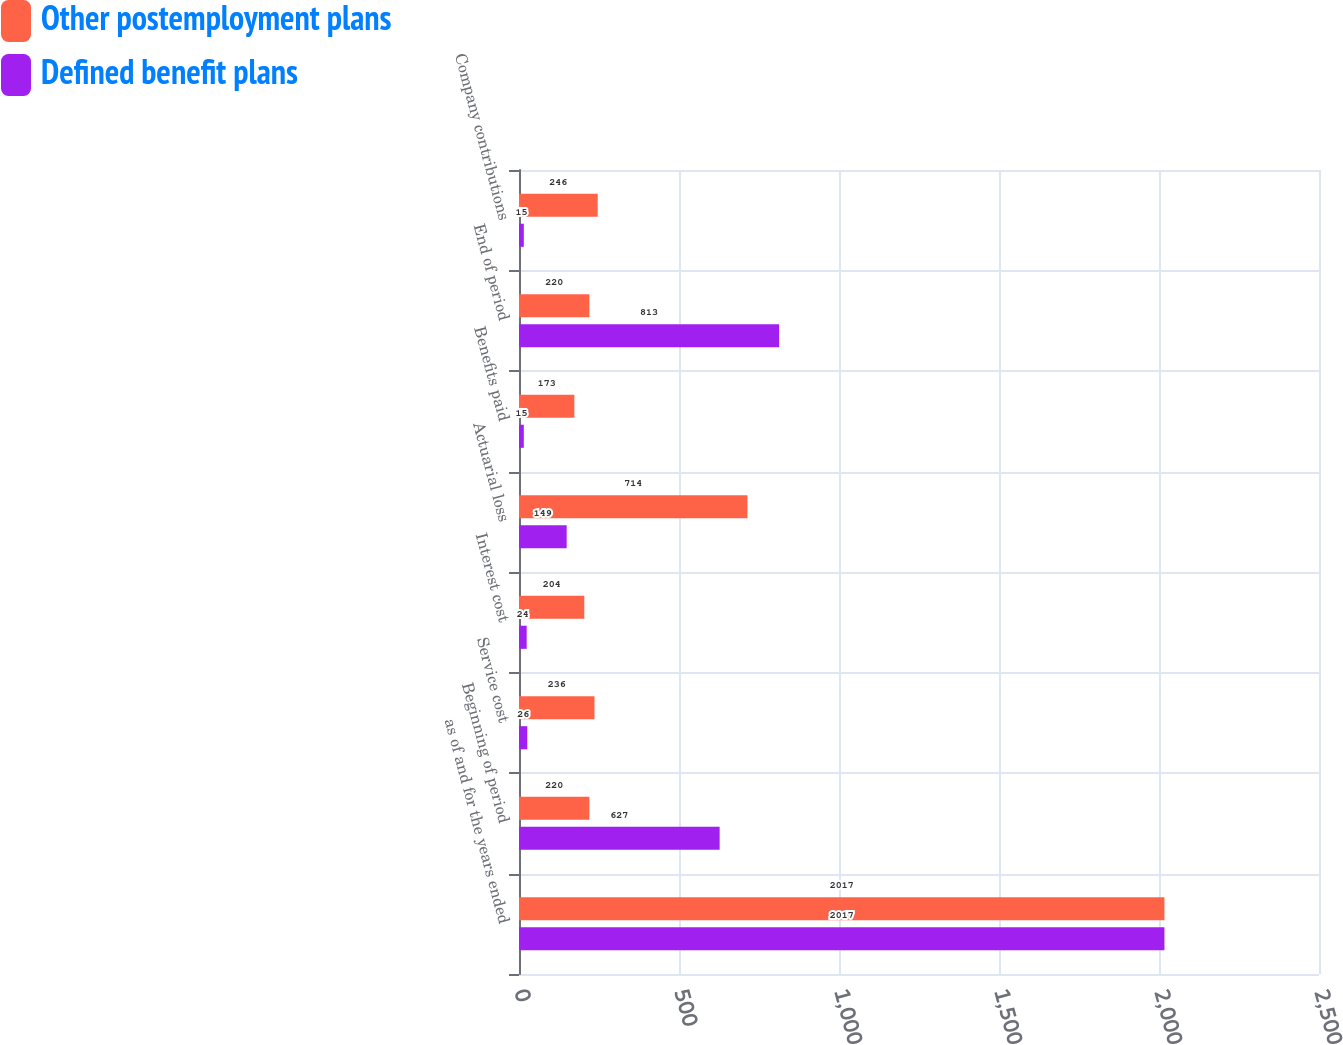<chart> <loc_0><loc_0><loc_500><loc_500><stacked_bar_chart><ecel><fcel>as of and for the years ended<fcel>Beginning of period<fcel>Service cost<fcel>Interest cost<fcel>Actuarial loss<fcel>Benefits paid<fcel>End of period<fcel>Company contributions<nl><fcel>Other postemployment plans<fcel>2017<fcel>220<fcel>236<fcel>204<fcel>714<fcel>173<fcel>220<fcel>246<nl><fcel>Defined benefit plans<fcel>2017<fcel>627<fcel>26<fcel>24<fcel>149<fcel>15<fcel>813<fcel>15<nl></chart> 